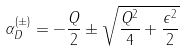Convert formula to latex. <formula><loc_0><loc_0><loc_500><loc_500>\alpha _ { D } ^ { ( \pm ) } = - \frac { Q } { 2 } \pm \sqrt { \frac { Q ^ { 2 } } { 4 } + \frac { \epsilon ^ { 2 } } { 2 } }</formula> 